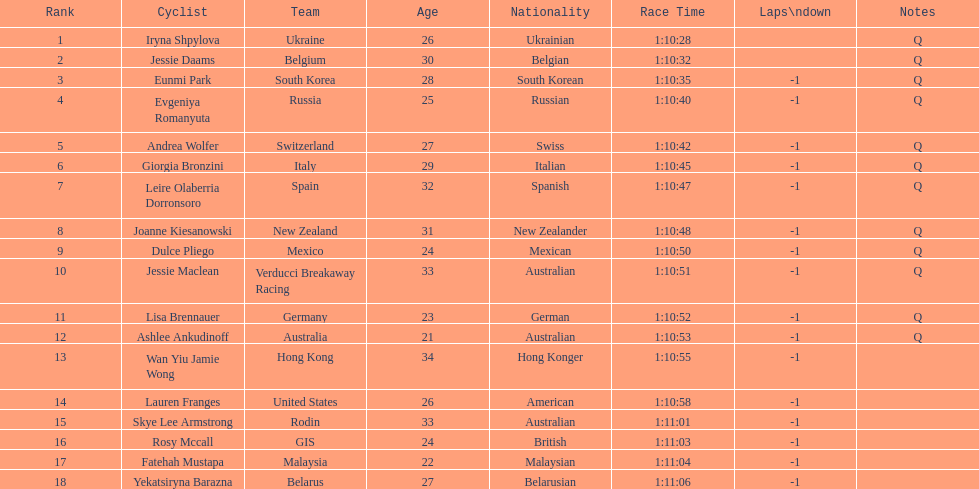Would you mind parsing the complete table? {'header': ['Rank', 'Cyclist', 'Team', 'Age', 'Nationality', 'Race Time', 'Laps\\ndown', 'Notes'], 'rows': [['1', 'Iryna Shpylova', 'Ukraine', '26', 'Ukrainian', '1:10:28', '', 'Q'], ['2', 'Jessie Daams', 'Belgium', '30', 'Belgian', '1:10:32', '', 'Q'], ['3', 'Eunmi Park', 'South Korea', '28', 'South Korean', '1:10:35', '-1', 'Q'], ['4', 'Evgeniya Romanyuta', 'Russia', '25', 'Russian', '1:10:40', '-1', 'Q'], ['5', 'Andrea Wolfer', 'Switzerland', '27', 'Swiss', '1:10:42', '-1', 'Q'], ['6', 'Giorgia Bronzini', 'Italy', '29', 'Italian', '1:10:45', '-1', 'Q'], ['7', 'Leire Olaberria Dorronsoro', 'Spain', '32', 'Spanish', '1:10:47', '-1', 'Q'], ['8', 'Joanne Kiesanowski', 'New Zealand', '31', 'New Zealander', '1:10:48', '-1', 'Q'], ['9', 'Dulce Pliego', 'Mexico', '24', 'Mexican', '1:10:50', '-1', 'Q'], ['10', 'Jessie Maclean', 'Verducci Breakaway Racing', '33', 'Australian', '1:10:51', '-1', 'Q'], ['11', 'Lisa Brennauer', 'Germany', '23', 'German', '1:10:52', '-1', 'Q'], ['12', 'Ashlee Ankudinoff', 'Australia', '21', 'Australian', '1:10:53', '-1', 'Q'], ['13', 'Wan Yiu Jamie Wong', 'Hong Kong', '34', 'Hong Konger', '1:10:55', '-1', ''], ['14', 'Lauren Franges', 'United States', '26', 'American', '1:10:58', '-1', ''], ['15', 'Skye Lee Armstrong', 'Rodin', '33', 'Australian', '1:11:01', '-1', ''], ['16', 'Rosy Mccall', 'GIS', '24', 'British', '1:11:03', '-1', ''], ['17', 'Fatehah Mustapa', 'Malaysia', '22', 'Malaysian', '1:11:04', '-1', ''], ['18', 'Yekatsiryna Barazna', 'Belarus', '27', 'Belarusian', '1:11:06', '-1', '']]} How many cyclist do not have -1 laps down? 2. 